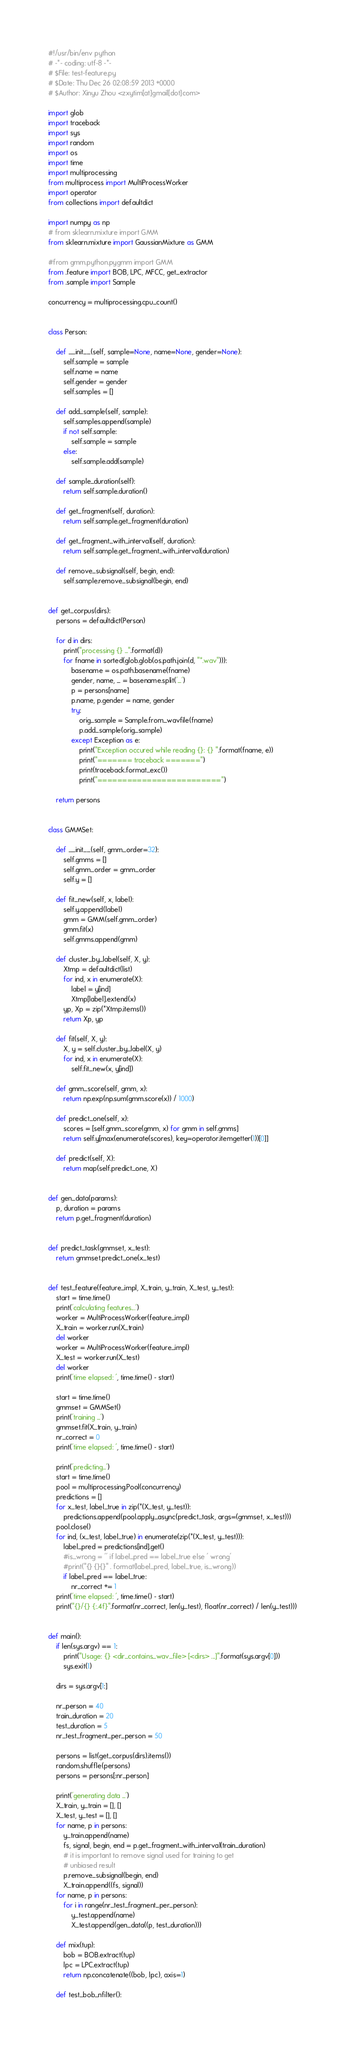<code> <loc_0><loc_0><loc_500><loc_500><_Python_>#!/usr/bin/env python
# -*- coding: utf-8 -*-
# $File: test-feature.py
# $Date: Thu Dec 26 02:08:59 2013 +0000
# $Author: Xinyu Zhou <zxytim[at]gmail[dot]com>

import glob
import traceback
import sys
import random
import os
import time
import multiprocessing
from multiprocess import MultiProcessWorker
import operator
from collections import defaultdict

import numpy as np
# from sklearn.mixture import GMM
from sklearn.mixture import GaussianMixture as GMM

#from gmm.python.pygmm import GMM
from .feature import BOB, LPC, MFCC, get_extractor
from .sample import Sample

concurrency = multiprocessing.cpu_count()


class Person:

    def __init__(self, sample=None, name=None, gender=None):
        self.sample = sample
        self.name = name
        self.gender = gender
        self.samples = []

    def add_sample(self, sample):
        self.samples.append(sample)
        if not self.sample:
            self.sample = sample
        else:
            self.sample.add(sample)

    def sample_duration(self):
        return self.sample.duration()

    def get_fragment(self, duration):
        return self.sample.get_fragment(duration)

    def get_fragment_with_interval(self, duration):
        return self.sample.get_fragment_with_interval(duration)

    def remove_subsignal(self, begin, end):
        self.sample.remove_subsignal(begin, end)


def get_corpus(dirs):
    persons = defaultdict(Person)

    for d in dirs:
        print("processing {} ...".format(d))
        for fname in sorted(glob.glob(os.path.join(d, "*.wav"))):
            basename = os.path.basename(fname)
            gender, name, _ = basename.split('_')
            p = persons[name]
            p.name, p.gender = name, gender
            try:
                orig_sample = Sample.from_wavfile(fname)
                p.add_sample(orig_sample)
            except Exception as e:
                print("Exception occured while reading {}: {} ".format(fname, e))
                print("======= traceback =======")
                print(traceback.format_exc())
                print("=========================")

    return persons


class GMMSet:

    def __init__(self, gmm_order=32):
        self.gmms = []
        self.gmm_order = gmm_order
        self.y = []

    def fit_new(self, x, label):
        self.y.append(label)
        gmm = GMM(self.gmm_order)
        gmm.fit(x)
        self.gmms.append(gmm)

    def cluster_by_label(self, X, y):
        Xtmp = defaultdict(list)
        for ind, x in enumerate(X):
            label = y[ind]
            Xtmp[label].extend(x)
        yp, Xp = zip(*Xtmp.items())
        return Xp, yp

    def fit(self, X, y):
        X, y = self.cluster_by_label(X, y)
        for ind, x in enumerate(X):
            self.fit_new(x, y[ind])

    def gmm_score(self, gmm, x):
        return np.exp(np.sum(gmm.score(x)) / 1000)

    def predict_one(self, x):
        scores = [self.gmm_score(gmm, x) for gmm in self.gmms]
        return self.y[max(enumerate(scores), key=operator.itemgetter(1))[0]]

    def predict(self, X):
        return map(self.predict_one, X)


def gen_data(params):
    p, duration = params
    return p.get_fragment(duration)


def predict_task(gmmset, x_test):
    return gmmset.predict_one(x_test)


def test_feature(feature_impl, X_train, y_train, X_test, y_test):
    start = time.time()
    print('calculating features...')
    worker = MultiProcessWorker(feature_impl)
    X_train = worker.run(X_train)
    del worker
    worker = MultiProcessWorker(feature_impl)
    X_test = worker.run(X_test)
    del worker
    print('time elapsed: ', time.time() - start)

    start = time.time()
    gmmset = GMMSet()
    print('training ...')
    gmmset.fit(X_train, y_train)
    nr_correct = 0
    print('time elapsed: ', time.time() - start)

    print('predicting...')
    start = time.time()
    pool = multiprocessing.Pool(concurrency)
    predictions = []
    for x_test, label_true in zip(*(X_test, y_test)):
        predictions.append(pool.apply_async(predict_task, args=(gmmset, x_test)))
    pool.close()
    for ind, (x_test, label_true) in enumerate(zip(*(X_test, y_test))):
        label_pred = predictions[ind].get()
        #is_wrong = '' if label_pred == label_true else ' wrong'
        #print("{} {}{}" . format(label_pred, label_true, is_wrong))
        if label_pred == label_true:
            nr_correct += 1
    print('time elapsed: ', time.time() - start)
    print("{}/{} {:.4f}".format(nr_correct, len(y_test), float(nr_correct) / len(y_test)))


def main():
    if len(sys.argv) == 1:
        print("Usage: {} <dir_contains_wav_file> [<dirs> ...]".format(sys.argv[0]))
        sys.exit(1)

    dirs = sys.argv[1:]

    nr_person = 40
    train_duration = 20
    test_duration = 5
    nr_test_fragment_per_person = 50

    persons = list(get_corpus(dirs).items())
    random.shuffle(persons)
    persons = persons[:nr_person]

    print('generating data ...')
    X_train, y_train = [], []
    X_test, y_test = [], []
    for name, p in persons:
        y_train.append(name)
        fs, signal, begin, end = p.get_fragment_with_interval(train_duration)
        # it is important to remove signal used for training to get
        # unbiased result
        p.remove_subsignal(begin, end)
        X_train.append((fs, signal))
    for name, p in persons:
        for i in range(nr_test_fragment_per_person):
            y_test.append(name)
            X_test.append(gen_data((p, test_duration)))

    def mix(tup):
        bob = BOB.extract(tup)
        lpc = LPC.extract(tup)
        return np.concatenate((bob, lpc), axis=1)

    def test_bob_nfilter():</code> 